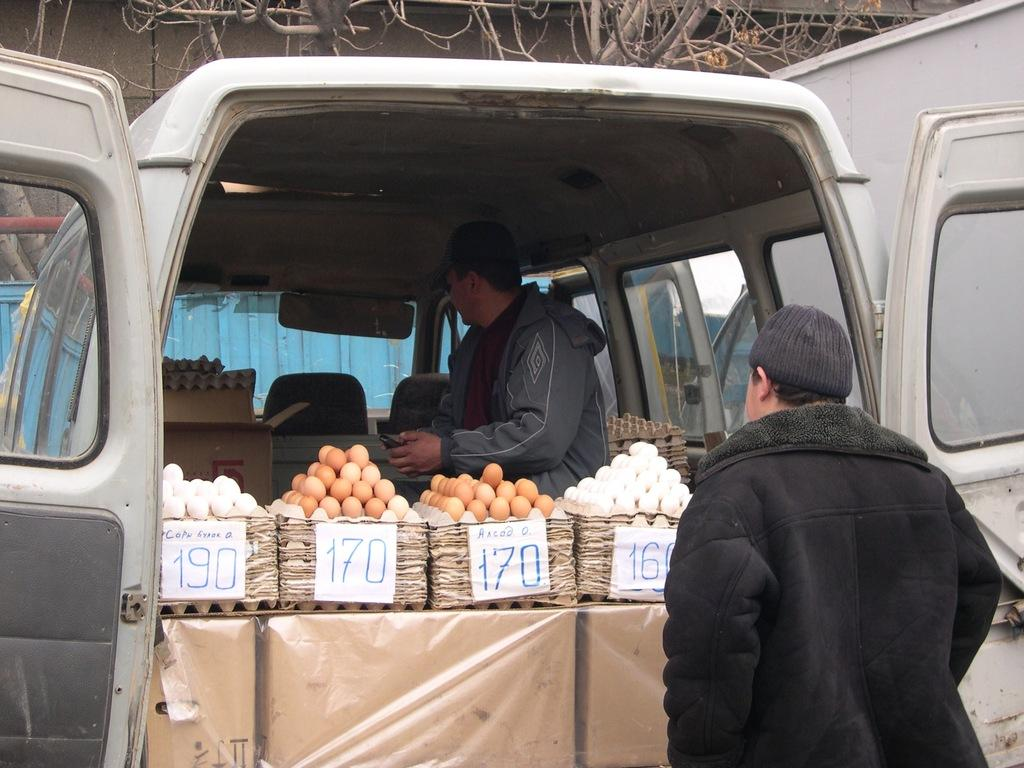What is the main subject of the image? There is a man standing in the image. What can be seen in the background of the image? There are eggs and a shed visible in the background of the image. What is the man doing in the image? The man is sitting in a car. What type of clam is being used to make a decision in the image? There is no clam present or decision-making process depicted in the image. 